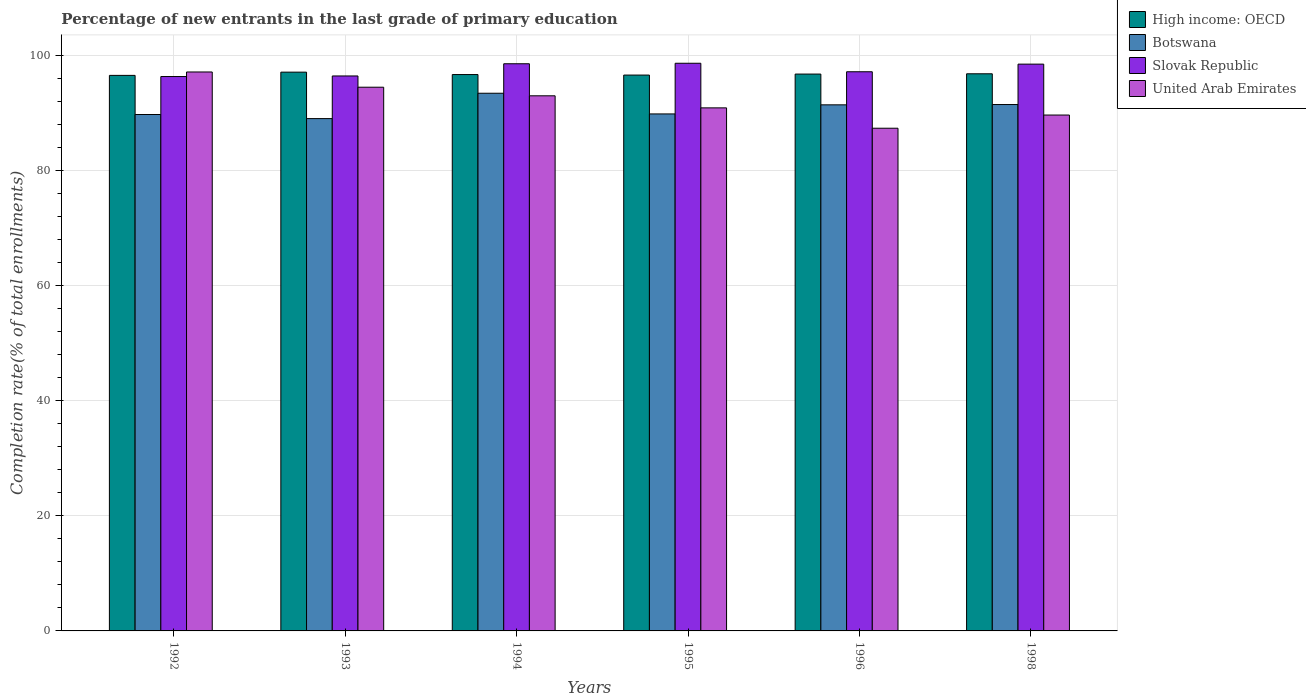Are the number of bars on each tick of the X-axis equal?
Keep it short and to the point. Yes. How many bars are there on the 4th tick from the right?
Your answer should be compact. 4. In how many cases, is the number of bars for a given year not equal to the number of legend labels?
Provide a succinct answer. 0. What is the percentage of new entrants in Slovak Republic in 1996?
Ensure brevity in your answer.  97.13. Across all years, what is the maximum percentage of new entrants in United Arab Emirates?
Ensure brevity in your answer.  97.09. Across all years, what is the minimum percentage of new entrants in Botswana?
Your answer should be compact. 89. In which year was the percentage of new entrants in United Arab Emirates maximum?
Make the answer very short. 1992. What is the total percentage of new entrants in Slovak Republic in the graph?
Offer a terse response. 585.43. What is the difference between the percentage of new entrants in Slovak Republic in 1993 and that in 1998?
Make the answer very short. -2.05. What is the difference between the percentage of new entrants in Slovak Republic in 1992 and the percentage of new entrants in Botswana in 1996?
Your response must be concise. 4.92. What is the average percentage of new entrants in United Arab Emirates per year?
Provide a short and direct response. 92.05. In the year 1996, what is the difference between the percentage of new entrants in United Arab Emirates and percentage of new entrants in Botswana?
Offer a very short reply. -4.06. In how many years, is the percentage of new entrants in Slovak Republic greater than 24 %?
Offer a terse response. 6. What is the ratio of the percentage of new entrants in Botswana in 1994 to that in 1998?
Keep it short and to the point. 1.02. What is the difference between the highest and the second highest percentage of new entrants in United Arab Emirates?
Your answer should be compact. 2.65. What is the difference between the highest and the lowest percentage of new entrants in United Arab Emirates?
Give a very brief answer. 9.77. Is the sum of the percentage of new entrants in United Arab Emirates in 1996 and 1998 greater than the maximum percentage of new entrants in Slovak Republic across all years?
Offer a terse response. Yes. Is it the case that in every year, the sum of the percentage of new entrants in Botswana and percentage of new entrants in Slovak Republic is greater than the sum of percentage of new entrants in United Arab Emirates and percentage of new entrants in High income: OECD?
Offer a very short reply. Yes. What does the 1st bar from the left in 1998 represents?
Provide a short and direct response. High income: OECD. What does the 3rd bar from the right in 1995 represents?
Your answer should be compact. Botswana. Is it the case that in every year, the sum of the percentage of new entrants in Slovak Republic and percentage of new entrants in Botswana is greater than the percentage of new entrants in United Arab Emirates?
Provide a short and direct response. Yes. How many bars are there?
Provide a succinct answer. 24. Does the graph contain any zero values?
Your answer should be compact. No. How many legend labels are there?
Give a very brief answer. 4. How are the legend labels stacked?
Your answer should be compact. Vertical. What is the title of the graph?
Your answer should be very brief. Percentage of new entrants in the last grade of primary education. What is the label or title of the Y-axis?
Your response must be concise. Completion rate(% of total enrollments). What is the Completion rate(% of total enrollments) in High income: OECD in 1992?
Provide a succinct answer. 96.5. What is the Completion rate(% of total enrollments) in Botswana in 1992?
Make the answer very short. 89.71. What is the Completion rate(% of total enrollments) in Slovak Republic in 1992?
Offer a very short reply. 96.3. What is the Completion rate(% of total enrollments) of United Arab Emirates in 1992?
Give a very brief answer. 97.09. What is the Completion rate(% of total enrollments) of High income: OECD in 1993?
Your answer should be compact. 97.07. What is the Completion rate(% of total enrollments) in Botswana in 1993?
Your response must be concise. 89. What is the Completion rate(% of total enrollments) of Slovak Republic in 1993?
Offer a very short reply. 96.4. What is the Completion rate(% of total enrollments) of United Arab Emirates in 1993?
Make the answer very short. 94.45. What is the Completion rate(% of total enrollments) in High income: OECD in 1994?
Offer a very short reply. 96.65. What is the Completion rate(% of total enrollments) of Botswana in 1994?
Provide a succinct answer. 93.4. What is the Completion rate(% of total enrollments) in Slovak Republic in 1994?
Ensure brevity in your answer.  98.52. What is the Completion rate(% of total enrollments) in United Arab Emirates in 1994?
Offer a terse response. 92.96. What is the Completion rate(% of total enrollments) of High income: OECD in 1995?
Your answer should be very brief. 96.56. What is the Completion rate(% of total enrollments) in Botswana in 1995?
Make the answer very short. 89.81. What is the Completion rate(% of total enrollments) in Slovak Republic in 1995?
Keep it short and to the point. 98.61. What is the Completion rate(% of total enrollments) of United Arab Emirates in 1995?
Your answer should be compact. 90.86. What is the Completion rate(% of total enrollments) of High income: OECD in 1996?
Your answer should be very brief. 96.73. What is the Completion rate(% of total enrollments) in Botswana in 1996?
Keep it short and to the point. 91.39. What is the Completion rate(% of total enrollments) in Slovak Republic in 1996?
Give a very brief answer. 97.13. What is the Completion rate(% of total enrollments) in United Arab Emirates in 1996?
Ensure brevity in your answer.  87.32. What is the Completion rate(% of total enrollments) of High income: OECD in 1998?
Offer a very short reply. 96.78. What is the Completion rate(% of total enrollments) of Botswana in 1998?
Offer a very short reply. 91.44. What is the Completion rate(% of total enrollments) in Slovak Republic in 1998?
Offer a very short reply. 98.46. What is the Completion rate(% of total enrollments) of United Arab Emirates in 1998?
Your answer should be very brief. 89.62. Across all years, what is the maximum Completion rate(% of total enrollments) in High income: OECD?
Keep it short and to the point. 97.07. Across all years, what is the maximum Completion rate(% of total enrollments) in Botswana?
Your answer should be compact. 93.4. Across all years, what is the maximum Completion rate(% of total enrollments) in Slovak Republic?
Ensure brevity in your answer.  98.61. Across all years, what is the maximum Completion rate(% of total enrollments) of United Arab Emirates?
Your answer should be very brief. 97.09. Across all years, what is the minimum Completion rate(% of total enrollments) in High income: OECD?
Offer a very short reply. 96.5. Across all years, what is the minimum Completion rate(% of total enrollments) of Botswana?
Offer a terse response. 89. Across all years, what is the minimum Completion rate(% of total enrollments) in Slovak Republic?
Your response must be concise. 96.3. Across all years, what is the minimum Completion rate(% of total enrollments) of United Arab Emirates?
Ensure brevity in your answer.  87.32. What is the total Completion rate(% of total enrollments) in High income: OECD in the graph?
Your answer should be compact. 580.29. What is the total Completion rate(% of total enrollments) in Botswana in the graph?
Make the answer very short. 544.74. What is the total Completion rate(% of total enrollments) of Slovak Republic in the graph?
Give a very brief answer. 585.43. What is the total Completion rate(% of total enrollments) of United Arab Emirates in the graph?
Give a very brief answer. 552.3. What is the difference between the Completion rate(% of total enrollments) in High income: OECD in 1992 and that in 1993?
Provide a short and direct response. -0.56. What is the difference between the Completion rate(% of total enrollments) of Botswana in 1992 and that in 1993?
Your answer should be very brief. 0.71. What is the difference between the Completion rate(% of total enrollments) in Slovak Republic in 1992 and that in 1993?
Provide a short and direct response. -0.1. What is the difference between the Completion rate(% of total enrollments) in United Arab Emirates in 1992 and that in 1993?
Keep it short and to the point. 2.65. What is the difference between the Completion rate(% of total enrollments) in High income: OECD in 1992 and that in 1994?
Give a very brief answer. -0.14. What is the difference between the Completion rate(% of total enrollments) of Botswana in 1992 and that in 1994?
Offer a very short reply. -3.69. What is the difference between the Completion rate(% of total enrollments) in Slovak Republic in 1992 and that in 1994?
Offer a terse response. -2.22. What is the difference between the Completion rate(% of total enrollments) of United Arab Emirates in 1992 and that in 1994?
Ensure brevity in your answer.  4.14. What is the difference between the Completion rate(% of total enrollments) in High income: OECD in 1992 and that in 1995?
Provide a short and direct response. -0.06. What is the difference between the Completion rate(% of total enrollments) in Botswana in 1992 and that in 1995?
Make the answer very short. -0.1. What is the difference between the Completion rate(% of total enrollments) of Slovak Republic in 1992 and that in 1995?
Give a very brief answer. -2.31. What is the difference between the Completion rate(% of total enrollments) in United Arab Emirates in 1992 and that in 1995?
Provide a short and direct response. 6.23. What is the difference between the Completion rate(% of total enrollments) of High income: OECD in 1992 and that in 1996?
Your answer should be compact. -0.23. What is the difference between the Completion rate(% of total enrollments) in Botswana in 1992 and that in 1996?
Ensure brevity in your answer.  -1.68. What is the difference between the Completion rate(% of total enrollments) in Slovak Republic in 1992 and that in 1996?
Your answer should be very brief. -0.83. What is the difference between the Completion rate(% of total enrollments) in United Arab Emirates in 1992 and that in 1996?
Give a very brief answer. 9.77. What is the difference between the Completion rate(% of total enrollments) of High income: OECD in 1992 and that in 1998?
Your answer should be compact. -0.28. What is the difference between the Completion rate(% of total enrollments) in Botswana in 1992 and that in 1998?
Offer a very short reply. -1.73. What is the difference between the Completion rate(% of total enrollments) of Slovak Republic in 1992 and that in 1998?
Offer a very short reply. -2.16. What is the difference between the Completion rate(% of total enrollments) in United Arab Emirates in 1992 and that in 1998?
Make the answer very short. 7.48. What is the difference between the Completion rate(% of total enrollments) in High income: OECD in 1993 and that in 1994?
Your response must be concise. 0.42. What is the difference between the Completion rate(% of total enrollments) in Botswana in 1993 and that in 1994?
Provide a succinct answer. -4.4. What is the difference between the Completion rate(% of total enrollments) of Slovak Republic in 1993 and that in 1994?
Keep it short and to the point. -2.12. What is the difference between the Completion rate(% of total enrollments) in United Arab Emirates in 1993 and that in 1994?
Your response must be concise. 1.49. What is the difference between the Completion rate(% of total enrollments) of High income: OECD in 1993 and that in 1995?
Offer a very short reply. 0.51. What is the difference between the Completion rate(% of total enrollments) of Botswana in 1993 and that in 1995?
Give a very brief answer. -0.81. What is the difference between the Completion rate(% of total enrollments) in Slovak Republic in 1993 and that in 1995?
Offer a very short reply. -2.21. What is the difference between the Completion rate(% of total enrollments) in United Arab Emirates in 1993 and that in 1995?
Offer a terse response. 3.59. What is the difference between the Completion rate(% of total enrollments) of High income: OECD in 1993 and that in 1996?
Make the answer very short. 0.33. What is the difference between the Completion rate(% of total enrollments) of Botswana in 1993 and that in 1996?
Your response must be concise. -2.39. What is the difference between the Completion rate(% of total enrollments) in Slovak Republic in 1993 and that in 1996?
Provide a succinct answer. -0.73. What is the difference between the Completion rate(% of total enrollments) in United Arab Emirates in 1993 and that in 1996?
Provide a short and direct response. 7.13. What is the difference between the Completion rate(% of total enrollments) in High income: OECD in 1993 and that in 1998?
Ensure brevity in your answer.  0.28. What is the difference between the Completion rate(% of total enrollments) of Botswana in 1993 and that in 1998?
Ensure brevity in your answer.  -2.44. What is the difference between the Completion rate(% of total enrollments) in Slovak Republic in 1993 and that in 1998?
Your answer should be very brief. -2.05. What is the difference between the Completion rate(% of total enrollments) of United Arab Emirates in 1993 and that in 1998?
Your response must be concise. 4.83. What is the difference between the Completion rate(% of total enrollments) in High income: OECD in 1994 and that in 1995?
Provide a succinct answer. 0.09. What is the difference between the Completion rate(% of total enrollments) in Botswana in 1994 and that in 1995?
Keep it short and to the point. 3.59. What is the difference between the Completion rate(% of total enrollments) of Slovak Republic in 1994 and that in 1995?
Give a very brief answer. -0.09. What is the difference between the Completion rate(% of total enrollments) in United Arab Emirates in 1994 and that in 1995?
Provide a succinct answer. 2.09. What is the difference between the Completion rate(% of total enrollments) of High income: OECD in 1994 and that in 1996?
Make the answer very short. -0.09. What is the difference between the Completion rate(% of total enrollments) of Botswana in 1994 and that in 1996?
Your answer should be compact. 2.01. What is the difference between the Completion rate(% of total enrollments) of Slovak Republic in 1994 and that in 1996?
Ensure brevity in your answer.  1.39. What is the difference between the Completion rate(% of total enrollments) in United Arab Emirates in 1994 and that in 1996?
Provide a short and direct response. 5.63. What is the difference between the Completion rate(% of total enrollments) of High income: OECD in 1994 and that in 1998?
Your answer should be very brief. -0.13. What is the difference between the Completion rate(% of total enrollments) of Botswana in 1994 and that in 1998?
Make the answer very short. 1.96. What is the difference between the Completion rate(% of total enrollments) in Slovak Republic in 1994 and that in 1998?
Your answer should be very brief. 0.07. What is the difference between the Completion rate(% of total enrollments) of United Arab Emirates in 1994 and that in 1998?
Make the answer very short. 3.34. What is the difference between the Completion rate(% of total enrollments) in High income: OECD in 1995 and that in 1996?
Your answer should be very brief. -0.18. What is the difference between the Completion rate(% of total enrollments) in Botswana in 1995 and that in 1996?
Provide a succinct answer. -1.58. What is the difference between the Completion rate(% of total enrollments) of Slovak Republic in 1995 and that in 1996?
Your answer should be very brief. 1.48. What is the difference between the Completion rate(% of total enrollments) in United Arab Emirates in 1995 and that in 1996?
Offer a terse response. 3.54. What is the difference between the Completion rate(% of total enrollments) of High income: OECD in 1995 and that in 1998?
Give a very brief answer. -0.22. What is the difference between the Completion rate(% of total enrollments) of Botswana in 1995 and that in 1998?
Keep it short and to the point. -1.63. What is the difference between the Completion rate(% of total enrollments) of Slovak Republic in 1995 and that in 1998?
Make the answer very short. 0.15. What is the difference between the Completion rate(% of total enrollments) of United Arab Emirates in 1995 and that in 1998?
Give a very brief answer. 1.25. What is the difference between the Completion rate(% of total enrollments) of High income: OECD in 1996 and that in 1998?
Ensure brevity in your answer.  -0.05. What is the difference between the Completion rate(% of total enrollments) in Botswana in 1996 and that in 1998?
Provide a short and direct response. -0.05. What is the difference between the Completion rate(% of total enrollments) in Slovak Republic in 1996 and that in 1998?
Your response must be concise. -1.32. What is the difference between the Completion rate(% of total enrollments) in United Arab Emirates in 1996 and that in 1998?
Your answer should be compact. -2.29. What is the difference between the Completion rate(% of total enrollments) in High income: OECD in 1992 and the Completion rate(% of total enrollments) in Botswana in 1993?
Offer a very short reply. 7.51. What is the difference between the Completion rate(% of total enrollments) of High income: OECD in 1992 and the Completion rate(% of total enrollments) of Slovak Republic in 1993?
Keep it short and to the point. 0.1. What is the difference between the Completion rate(% of total enrollments) of High income: OECD in 1992 and the Completion rate(% of total enrollments) of United Arab Emirates in 1993?
Provide a succinct answer. 2.05. What is the difference between the Completion rate(% of total enrollments) in Botswana in 1992 and the Completion rate(% of total enrollments) in Slovak Republic in 1993?
Keep it short and to the point. -6.7. What is the difference between the Completion rate(% of total enrollments) of Botswana in 1992 and the Completion rate(% of total enrollments) of United Arab Emirates in 1993?
Your answer should be very brief. -4.74. What is the difference between the Completion rate(% of total enrollments) of Slovak Republic in 1992 and the Completion rate(% of total enrollments) of United Arab Emirates in 1993?
Your response must be concise. 1.85. What is the difference between the Completion rate(% of total enrollments) in High income: OECD in 1992 and the Completion rate(% of total enrollments) in Botswana in 1994?
Make the answer very short. 3.1. What is the difference between the Completion rate(% of total enrollments) in High income: OECD in 1992 and the Completion rate(% of total enrollments) in Slovak Republic in 1994?
Provide a short and direct response. -2.02. What is the difference between the Completion rate(% of total enrollments) of High income: OECD in 1992 and the Completion rate(% of total enrollments) of United Arab Emirates in 1994?
Your answer should be very brief. 3.55. What is the difference between the Completion rate(% of total enrollments) in Botswana in 1992 and the Completion rate(% of total enrollments) in Slovak Republic in 1994?
Your answer should be very brief. -8.82. What is the difference between the Completion rate(% of total enrollments) in Botswana in 1992 and the Completion rate(% of total enrollments) in United Arab Emirates in 1994?
Offer a terse response. -3.25. What is the difference between the Completion rate(% of total enrollments) in Slovak Republic in 1992 and the Completion rate(% of total enrollments) in United Arab Emirates in 1994?
Your answer should be very brief. 3.35. What is the difference between the Completion rate(% of total enrollments) in High income: OECD in 1992 and the Completion rate(% of total enrollments) in Botswana in 1995?
Give a very brief answer. 6.69. What is the difference between the Completion rate(% of total enrollments) of High income: OECD in 1992 and the Completion rate(% of total enrollments) of Slovak Republic in 1995?
Your response must be concise. -2.11. What is the difference between the Completion rate(% of total enrollments) in High income: OECD in 1992 and the Completion rate(% of total enrollments) in United Arab Emirates in 1995?
Provide a short and direct response. 5.64. What is the difference between the Completion rate(% of total enrollments) in Botswana in 1992 and the Completion rate(% of total enrollments) in Slovak Republic in 1995?
Make the answer very short. -8.9. What is the difference between the Completion rate(% of total enrollments) of Botswana in 1992 and the Completion rate(% of total enrollments) of United Arab Emirates in 1995?
Keep it short and to the point. -1.15. What is the difference between the Completion rate(% of total enrollments) of Slovak Republic in 1992 and the Completion rate(% of total enrollments) of United Arab Emirates in 1995?
Your response must be concise. 5.44. What is the difference between the Completion rate(% of total enrollments) of High income: OECD in 1992 and the Completion rate(% of total enrollments) of Botswana in 1996?
Your response must be concise. 5.12. What is the difference between the Completion rate(% of total enrollments) of High income: OECD in 1992 and the Completion rate(% of total enrollments) of Slovak Republic in 1996?
Provide a succinct answer. -0.63. What is the difference between the Completion rate(% of total enrollments) of High income: OECD in 1992 and the Completion rate(% of total enrollments) of United Arab Emirates in 1996?
Your answer should be compact. 9.18. What is the difference between the Completion rate(% of total enrollments) of Botswana in 1992 and the Completion rate(% of total enrollments) of Slovak Republic in 1996?
Provide a short and direct response. -7.43. What is the difference between the Completion rate(% of total enrollments) of Botswana in 1992 and the Completion rate(% of total enrollments) of United Arab Emirates in 1996?
Your answer should be compact. 2.38. What is the difference between the Completion rate(% of total enrollments) of Slovak Republic in 1992 and the Completion rate(% of total enrollments) of United Arab Emirates in 1996?
Offer a very short reply. 8.98. What is the difference between the Completion rate(% of total enrollments) in High income: OECD in 1992 and the Completion rate(% of total enrollments) in Botswana in 1998?
Offer a terse response. 5.06. What is the difference between the Completion rate(% of total enrollments) of High income: OECD in 1992 and the Completion rate(% of total enrollments) of Slovak Republic in 1998?
Give a very brief answer. -1.95. What is the difference between the Completion rate(% of total enrollments) in High income: OECD in 1992 and the Completion rate(% of total enrollments) in United Arab Emirates in 1998?
Give a very brief answer. 6.89. What is the difference between the Completion rate(% of total enrollments) of Botswana in 1992 and the Completion rate(% of total enrollments) of Slovak Republic in 1998?
Keep it short and to the point. -8.75. What is the difference between the Completion rate(% of total enrollments) in Botswana in 1992 and the Completion rate(% of total enrollments) in United Arab Emirates in 1998?
Ensure brevity in your answer.  0.09. What is the difference between the Completion rate(% of total enrollments) in Slovak Republic in 1992 and the Completion rate(% of total enrollments) in United Arab Emirates in 1998?
Make the answer very short. 6.69. What is the difference between the Completion rate(% of total enrollments) of High income: OECD in 1993 and the Completion rate(% of total enrollments) of Botswana in 1994?
Provide a succinct answer. 3.66. What is the difference between the Completion rate(% of total enrollments) of High income: OECD in 1993 and the Completion rate(% of total enrollments) of Slovak Republic in 1994?
Give a very brief answer. -1.46. What is the difference between the Completion rate(% of total enrollments) of High income: OECD in 1993 and the Completion rate(% of total enrollments) of United Arab Emirates in 1994?
Make the answer very short. 4.11. What is the difference between the Completion rate(% of total enrollments) of Botswana in 1993 and the Completion rate(% of total enrollments) of Slovak Republic in 1994?
Your response must be concise. -9.53. What is the difference between the Completion rate(% of total enrollments) of Botswana in 1993 and the Completion rate(% of total enrollments) of United Arab Emirates in 1994?
Provide a short and direct response. -3.96. What is the difference between the Completion rate(% of total enrollments) in Slovak Republic in 1993 and the Completion rate(% of total enrollments) in United Arab Emirates in 1994?
Keep it short and to the point. 3.45. What is the difference between the Completion rate(% of total enrollments) of High income: OECD in 1993 and the Completion rate(% of total enrollments) of Botswana in 1995?
Your response must be concise. 7.26. What is the difference between the Completion rate(% of total enrollments) of High income: OECD in 1993 and the Completion rate(% of total enrollments) of Slovak Republic in 1995?
Make the answer very short. -1.54. What is the difference between the Completion rate(% of total enrollments) of High income: OECD in 1993 and the Completion rate(% of total enrollments) of United Arab Emirates in 1995?
Provide a succinct answer. 6.2. What is the difference between the Completion rate(% of total enrollments) in Botswana in 1993 and the Completion rate(% of total enrollments) in Slovak Republic in 1995?
Provide a short and direct response. -9.61. What is the difference between the Completion rate(% of total enrollments) in Botswana in 1993 and the Completion rate(% of total enrollments) in United Arab Emirates in 1995?
Provide a short and direct response. -1.86. What is the difference between the Completion rate(% of total enrollments) of Slovak Republic in 1993 and the Completion rate(% of total enrollments) of United Arab Emirates in 1995?
Provide a succinct answer. 5.54. What is the difference between the Completion rate(% of total enrollments) of High income: OECD in 1993 and the Completion rate(% of total enrollments) of Botswana in 1996?
Your answer should be compact. 5.68. What is the difference between the Completion rate(% of total enrollments) in High income: OECD in 1993 and the Completion rate(% of total enrollments) in Slovak Republic in 1996?
Your response must be concise. -0.07. What is the difference between the Completion rate(% of total enrollments) of High income: OECD in 1993 and the Completion rate(% of total enrollments) of United Arab Emirates in 1996?
Make the answer very short. 9.74. What is the difference between the Completion rate(% of total enrollments) in Botswana in 1993 and the Completion rate(% of total enrollments) in Slovak Republic in 1996?
Offer a very short reply. -8.14. What is the difference between the Completion rate(% of total enrollments) in Botswana in 1993 and the Completion rate(% of total enrollments) in United Arab Emirates in 1996?
Ensure brevity in your answer.  1.67. What is the difference between the Completion rate(% of total enrollments) of Slovak Republic in 1993 and the Completion rate(% of total enrollments) of United Arab Emirates in 1996?
Offer a very short reply. 9.08. What is the difference between the Completion rate(% of total enrollments) of High income: OECD in 1993 and the Completion rate(% of total enrollments) of Botswana in 1998?
Make the answer very short. 5.62. What is the difference between the Completion rate(% of total enrollments) in High income: OECD in 1993 and the Completion rate(% of total enrollments) in Slovak Republic in 1998?
Your answer should be compact. -1.39. What is the difference between the Completion rate(% of total enrollments) of High income: OECD in 1993 and the Completion rate(% of total enrollments) of United Arab Emirates in 1998?
Offer a terse response. 7.45. What is the difference between the Completion rate(% of total enrollments) of Botswana in 1993 and the Completion rate(% of total enrollments) of Slovak Republic in 1998?
Make the answer very short. -9.46. What is the difference between the Completion rate(% of total enrollments) of Botswana in 1993 and the Completion rate(% of total enrollments) of United Arab Emirates in 1998?
Offer a very short reply. -0.62. What is the difference between the Completion rate(% of total enrollments) of Slovak Republic in 1993 and the Completion rate(% of total enrollments) of United Arab Emirates in 1998?
Ensure brevity in your answer.  6.79. What is the difference between the Completion rate(% of total enrollments) in High income: OECD in 1994 and the Completion rate(% of total enrollments) in Botswana in 1995?
Give a very brief answer. 6.84. What is the difference between the Completion rate(% of total enrollments) in High income: OECD in 1994 and the Completion rate(% of total enrollments) in Slovak Republic in 1995?
Offer a terse response. -1.96. What is the difference between the Completion rate(% of total enrollments) in High income: OECD in 1994 and the Completion rate(% of total enrollments) in United Arab Emirates in 1995?
Make the answer very short. 5.79. What is the difference between the Completion rate(% of total enrollments) of Botswana in 1994 and the Completion rate(% of total enrollments) of Slovak Republic in 1995?
Provide a short and direct response. -5.21. What is the difference between the Completion rate(% of total enrollments) in Botswana in 1994 and the Completion rate(% of total enrollments) in United Arab Emirates in 1995?
Make the answer very short. 2.54. What is the difference between the Completion rate(% of total enrollments) of Slovak Republic in 1994 and the Completion rate(% of total enrollments) of United Arab Emirates in 1995?
Your response must be concise. 7.66. What is the difference between the Completion rate(% of total enrollments) in High income: OECD in 1994 and the Completion rate(% of total enrollments) in Botswana in 1996?
Keep it short and to the point. 5.26. What is the difference between the Completion rate(% of total enrollments) in High income: OECD in 1994 and the Completion rate(% of total enrollments) in Slovak Republic in 1996?
Provide a short and direct response. -0.49. What is the difference between the Completion rate(% of total enrollments) in High income: OECD in 1994 and the Completion rate(% of total enrollments) in United Arab Emirates in 1996?
Your answer should be very brief. 9.32. What is the difference between the Completion rate(% of total enrollments) in Botswana in 1994 and the Completion rate(% of total enrollments) in Slovak Republic in 1996?
Make the answer very short. -3.73. What is the difference between the Completion rate(% of total enrollments) of Botswana in 1994 and the Completion rate(% of total enrollments) of United Arab Emirates in 1996?
Your answer should be very brief. 6.08. What is the difference between the Completion rate(% of total enrollments) in Slovak Republic in 1994 and the Completion rate(% of total enrollments) in United Arab Emirates in 1996?
Make the answer very short. 11.2. What is the difference between the Completion rate(% of total enrollments) in High income: OECD in 1994 and the Completion rate(% of total enrollments) in Botswana in 1998?
Keep it short and to the point. 5.21. What is the difference between the Completion rate(% of total enrollments) in High income: OECD in 1994 and the Completion rate(% of total enrollments) in Slovak Republic in 1998?
Make the answer very short. -1.81. What is the difference between the Completion rate(% of total enrollments) in High income: OECD in 1994 and the Completion rate(% of total enrollments) in United Arab Emirates in 1998?
Ensure brevity in your answer.  7.03. What is the difference between the Completion rate(% of total enrollments) of Botswana in 1994 and the Completion rate(% of total enrollments) of Slovak Republic in 1998?
Your answer should be very brief. -5.06. What is the difference between the Completion rate(% of total enrollments) in Botswana in 1994 and the Completion rate(% of total enrollments) in United Arab Emirates in 1998?
Give a very brief answer. 3.79. What is the difference between the Completion rate(% of total enrollments) in Slovak Republic in 1994 and the Completion rate(% of total enrollments) in United Arab Emirates in 1998?
Make the answer very short. 8.91. What is the difference between the Completion rate(% of total enrollments) in High income: OECD in 1995 and the Completion rate(% of total enrollments) in Botswana in 1996?
Offer a terse response. 5.17. What is the difference between the Completion rate(% of total enrollments) of High income: OECD in 1995 and the Completion rate(% of total enrollments) of Slovak Republic in 1996?
Keep it short and to the point. -0.58. What is the difference between the Completion rate(% of total enrollments) in High income: OECD in 1995 and the Completion rate(% of total enrollments) in United Arab Emirates in 1996?
Provide a succinct answer. 9.23. What is the difference between the Completion rate(% of total enrollments) of Botswana in 1995 and the Completion rate(% of total enrollments) of Slovak Republic in 1996?
Give a very brief answer. -7.33. What is the difference between the Completion rate(% of total enrollments) in Botswana in 1995 and the Completion rate(% of total enrollments) in United Arab Emirates in 1996?
Provide a succinct answer. 2.48. What is the difference between the Completion rate(% of total enrollments) of Slovak Republic in 1995 and the Completion rate(% of total enrollments) of United Arab Emirates in 1996?
Offer a terse response. 11.29. What is the difference between the Completion rate(% of total enrollments) of High income: OECD in 1995 and the Completion rate(% of total enrollments) of Botswana in 1998?
Give a very brief answer. 5.12. What is the difference between the Completion rate(% of total enrollments) of High income: OECD in 1995 and the Completion rate(% of total enrollments) of Slovak Republic in 1998?
Provide a short and direct response. -1.9. What is the difference between the Completion rate(% of total enrollments) of High income: OECD in 1995 and the Completion rate(% of total enrollments) of United Arab Emirates in 1998?
Your response must be concise. 6.94. What is the difference between the Completion rate(% of total enrollments) in Botswana in 1995 and the Completion rate(% of total enrollments) in Slovak Republic in 1998?
Keep it short and to the point. -8.65. What is the difference between the Completion rate(% of total enrollments) of Botswana in 1995 and the Completion rate(% of total enrollments) of United Arab Emirates in 1998?
Offer a very short reply. 0.19. What is the difference between the Completion rate(% of total enrollments) of Slovak Republic in 1995 and the Completion rate(% of total enrollments) of United Arab Emirates in 1998?
Your response must be concise. 8.99. What is the difference between the Completion rate(% of total enrollments) in High income: OECD in 1996 and the Completion rate(% of total enrollments) in Botswana in 1998?
Your answer should be very brief. 5.29. What is the difference between the Completion rate(% of total enrollments) in High income: OECD in 1996 and the Completion rate(% of total enrollments) in Slovak Republic in 1998?
Your answer should be compact. -1.72. What is the difference between the Completion rate(% of total enrollments) in High income: OECD in 1996 and the Completion rate(% of total enrollments) in United Arab Emirates in 1998?
Keep it short and to the point. 7.12. What is the difference between the Completion rate(% of total enrollments) of Botswana in 1996 and the Completion rate(% of total enrollments) of Slovak Republic in 1998?
Provide a short and direct response. -7.07. What is the difference between the Completion rate(% of total enrollments) in Botswana in 1996 and the Completion rate(% of total enrollments) in United Arab Emirates in 1998?
Ensure brevity in your answer.  1.77. What is the difference between the Completion rate(% of total enrollments) of Slovak Republic in 1996 and the Completion rate(% of total enrollments) of United Arab Emirates in 1998?
Your response must be concise. 7.52. What is the average Completion rate(% of total enrollments) of High income: OECD per year?
Offer a very short reply. 96.71. What is the average Completion rate(% of total enrollments) in Botswana per year?
Make the answer very short. 90.79. What is the average Completion rate(% of total enrollments) of Slovak Republic per year?
Ensure brevity in your answer.  97.57. What is the average Completion rate(% of total enrollments) in United Arab Emirates per year?
Your answer should be very brief. 92.05. In the year 1992, what is the difference between the Completion rate(% of total enrollments) in High income: OECD and Completion rate(% of total enrollments) in Botswana?
Offer a very short reply. 6.79. In the year 1992, what is the difference between the Completion rate(% of total enrollments) in High income: OECD and Completion rate(% of total enrollments) in Slovak Republic?
Your answer should be compact. 0.2. In the year 1992, what is the difference between the Completion rate(% of total enrollments) in High income: OECD and Completion rate(% of total enrollments) in United Arab Emirates?
Provide a short and direct response. -0.59. In the year 1992, what is the difference between the Completion rate(% of total enrollments) in Botswana and Completion rate(% of total enrollments) in Slovak Republic?
Make the answer very short. -6.59. In the year 1992, what is the difference between the Completion rate(% of total enrollments) of Botswana and Completion rate(% of total enrollments) of United Arab Emirates?
Offer a very short reply. -7.39. In the year 1992, what is the difference between the Completion rate(% of total enrollments) in Slovak Republic and Completion rate(% of total enrollments) in United Arab Emirates?
Your response must be concise. -0.79. In the year 1993, what is the difference between the Completion rate(% of total enrollments) of High income: OECD and Completion rate(% of total enrollments) of Botswana?
Provide a short and direct response. 8.07. In the year 1993, what is the difference between the Completion rate(% of total enrollments) in High income: OECD and Completion rate(% of total enrollments) in Slovak Republic?
Your response must be concise. 0.66. In the year 1993, what is the difference between the Completion rate(% of total enrollments) in High income: OECD and Completion rate(% of total enrollments) in United Arab Emirates?
Your response must be concise. 2.62. In the year 1993, what is the difference between the Completion rate(% of total enrollments) of Botswana and Completion rate(% of total enrollments) of Slovak Republic?
Offer a very short reply. -7.41. In the year 1993, what is the difference between the Completion rate(% of total enrollments) of Botswana and Completion rate(% of total enrollments) of United Arab Emirates?
Make the answer very short. -5.45. In the year 1993, what is the difference between the Completion rate(% of total enrollments) of Slovak Republic and Completion rate(% of total enrollments) of United Arab Emirates?
Your response must be concise. 1.95. In the year 1994, what is the difference between the Completion rate(% of total enrollments) in High income: OECD and Completion rate(% of total enrollments) in Botswana?
Your answer should be very brief. 3.25. In the year 1994, what is the difference between the Completion rate(% of total enrollments) in High income: OECD and Completion rate(% of total enrollments) in Slovak Republic?
Keep it short and to the point. -1.88. In the year 1994, what is the difference between the Completion rate(% of total enrollments) of High income: OECD and Completion rate(% of total enrollments) of United Arab Emirates?
Your response must be concise. 3.69. In the year 1994, what is the difference between the Completion rate(% of total enrollments) of Botswana and Completion rate(% of total enrollments) of Slovak Republic?
Make the answer very short. -5.12. In the year 1994, what is the difference between the Completion rate(% of total enrollments) of Botswana and Completion rate(% of total enrollments) of United Arab Emirates?
Ensure brevity in your answer.  0.44. In the year 1994, what is the difference between the Completion rate(% of total enrollments) of Slovak Republic and Completion rate(% of total enrollments) of United Arab Emirates?
Offer a very short reply. 5.57. In the year 1995, what is the difference between the Completion rate(% of total enrollments) in High income: OECD and Completion rate(% of total enrollments) in Botswana?
Provide a short and direct response. 6.75. In the year 1995, what is the difference between the Completion rate(% of total enrollments) in High income: OECD and Completion rate(% of total enrollments) in Slovak Republic?
Your answer should be compact. -2.05. In the year 1995, what is the difference between the Completion rate(% of total enrollments) of High income: OECD and Completion rate(% of total enrollments) of United Arab Emirates?
Give a very brief answer. 5.7. In the year 1995, what is the difference between the Completion rate(% of total enrollments) of Botswana and Completion rate(% of total enrollments) of Slovak Republic?
Ensure brevity in your answer.  -8.8. In the year 1995, what is the difference between the Completion rate(% of total enrollments) in Botswana and Completion rate(% of total enrollments) in United Arab Emirates?
Keep it short and to the point. -1.05. In the year 1995, what is the difference between the Completion rate(% of total enrollments) in Slovak Republic and Completion rate(% of total enrollments) in United Arab Emirates?
Offer a very short reply. 7.75. In the year 1996, what is the difference between the Completion rate(% of total enrollments) in High income: OECD and Completion rate(% of total enrollments) in Botswana?
Ensure brevity in your answer.  5.35. In the year 1996, what is the difference between the Completion rate(% of total enrollments) in High income: OECD and Completion rate(% of total enrollments) in Slovak Republic?
Offer a terse response. -0.4. In the year 1996, what is the difference between the Completion rate(% of total enrollments) in High income: OECD and Completion rate(% of total enrollments) in United Arab Emirates?
Your answer should be very brief. 9.41. In the year 1996, what is the difference between the Completion rate(% of total enrollments) of Botswana and Completion rate(% of total enrollments) of Slovak Republic?
Give a very brief answer. -5.75. In the year 1996, what is the difference between the Completion rate(% of total enrollments) in Botswana and Completion rate(% of total enrollments) in United Arab Emirates?
Provide a short and direct response. 4.06. In the year 1996, what is the difference between the Completion rate(% of total enrollments) in Slovak Republic and Completion rate(% of total enrollments) in United Arab Emirates?
Give a very brief answer. 9.81. In the year 1998, what is the difference between the Completion rate(% of total enrollments) in High income: OECD and Completion rate(% of total enrollments) in Botswana?
Make the answer very short. 5.34. In the year 1998, what is the difference between the Completion rate(% of total enrollments) in High income: OECD and Completion rate(% of total enrollments) in Slovak Republic?
Provide a short and direct response. -1.68. In the year 1998, what is the difference between the Completion rate(% of total enrollments) of High income: OECD and Completion rate(% of total enrollments) of United Arab Emirates?
Ensure brevity in your answer.  7.17. In the year 1998, what is the difference between the Completion rate(% of total enrollments) in Botswana and Completion rate(% of total enrollments) in Slovak Republic?
Ensure brevity in your answer.  -7.02. In the year 1998, what is the difference between the Completion rate(% of total enrollments) of Botswana and Completion rate(% of total enrollments) of United Arab Emirates?
Provide a succinct answer. 1.82. In the year 1998, what is the difference between the Completion rate(% of total enrollments) in Slovak Republic and Completion rate(% of total enrollments) in United Arab Emirates?
Ensure brevity in your answer.  8.84. What is the ratio of the Completion rate(% of total enrollments) of Botswana in 1992 to that in 1993?
Offer a terse response. 1.01. What is the ratio of the Completion rate(% of total enrollments) of United Arab Emirates in 1992 to that in 1993?
Provide a short and direct response. 1.03. What is the ratio of the Completion rate(% of total enrollments) of Botswana in 1992 to that in 1994?
Provide a short and direct response. 0.96. What is the ratio of the Completion rate(% of total enrollments) in Slovak Republic in 1992 to that in 1994?
Make the answer very short. 0.98. What is the ratio of the Completion rate(% of total enrollments) of United Arab Emirates in 1992 to that in 1994?
Your answer should be compact. 1.04. What is the ratio of the Completion rate(% of total enrollments) in High income: OECD in 1992 to that in 1995?
Keep it short and to the point. 1. What is the ratio of the Completion rate(% of total enrollments) of Slovak Republic in 1992 to that in 1995?
Your response must be concise. 0.98. What is the ratio of the Completion rate(% of total enrollments) of United Arab Emirates in 1992 to that in 1995?
Your answer should be compact. 1.07. What is the ratio of the Completion rate(% of total enrollments) of Botswana in 1992 to that in 1996?
Give a very brief answer. 0.98. What is the ratio of the Completion rate(% of total enrollments) of Slovak Republic in 1992 to that in 1996?
Provide a short and direct response. 0.99. What is the ratio of the Completion rate(% of total enrollments) of United Arab Emirates in 1992 to that in 1996?
Offer a very short reply. 1.11. What is the ratio of the Completion rate(% of total enrollments) of High income: OECD in 1992 to that in 1998?
Provide a succinct answer. 1. What is the ratio of the Completion rate(% of total enrollments) of Botswana in 1992 to that in 1998?
Your answer should be very brief. 0.98. What is the ratio of the Completion rate(% of total enrollments) in Slovak Republic in 1992 to that in 1998?
Ensure brevity in your answer.  0.98. What is the ratio of the Completion rate(% of total enrollments) in United Arab Emirates in 1992 to that in 1998?
Your answer should be very brief. 1.08. What is the ratio of the Completion rate(% of total enrollments) in High income: OECD in 1993 to that in 1994?
Provide a short and direct response. 1. What is the ratio of the Completion rate(% of total enrollments) of Botswana in 1993 to that in 1994?
Make the answer very short. 0.95. What is the ratio of the Completion rate(% of total enrollments) of Slovak Republic in 1993 to that in 1994?
Make the answer very short. 0.98. What is the ratio of the Completion rate(% of total enrollments) of United Arab Emirates in 1993 to that in 1994?
Ensure brevity in your answer.  1.02. What is the ratio of the Completion rate(% of total enrollments) in High income: OECD in 1993 to that in 1995?
Offer a terse response. 1.01. What is the ratio of the Completion rate(% of total enrollments) in Botswana in 1993 to that in 1995?
Give a very brief answer. 0.99. What is the ratio of the Completion rate(% of total enrollments) of Slovak Republic in 1993 to that in 1995?
Keep it short and to the point. 0.98. What is the ratio of the Completion rate(% of total enrollments) of United Arab Emirates in 1993 to that in 1995?
Make the answer very short. 1.04. What is the ratio of the Completion rate(% of total enrollments) in High income: OECD in 1993 to that in 1996?
Ensure brevity in your answer.  1. What is the ratio of the Completion rate(% of total enrollments) of Botswana in 1993 to that in 1996?
Your answer should be compact. 0.97. What is the ratio of the Completion rate(% of total enrollments) of United Arab Emirates in 1993 to that in 1996?
Provide a short and direct response. 1.08. What is the ratio of the Completion rate(% of total enrollments) in Botswana in 1993 to that in 1998?
Offer a terse response. 0.97. What is the ratio of the Completion rate(% of total enrollments) of Slovak Republic in 1993 to that in 1998?
Your answer should be compact. 0.98. What is the ratio of the Completion rate(% of total enrollments) of United Arab Emirates in 1993 to that in 1998?
Give a very brief answer. 1.05. What is the ratio of the Completion rate(% of total enrollments) in Slovak Republic in 1994 to that in 1995?
Offer a terse response. 1. What is the ratio of the Completion rate(% of total enrollments) of United Arab Emirates in 1994 to that in 1995?
Offer a very short reply. 1.02. What is the ratio of the Completion rate(% of total enrollments) in High income: OECD in 1994 to that in 1996?
Provide a short and direct response. 1. What is the ratio of the Completion rate(% of total enrollments) of Slovak Republic in 1994 to that in 1996?
Your answer should be very brief. 1.01. What is the ratio of the Completion rate(% of total enrollments) of United Arab Emirates in 1994 to that in 1996?
Your answer should be compact. 1.06. What is the ratio of the Completion rate(% of total enrollments) of Botswana in 1994 to that in 1998?
Your response must be concise. 1.02. What is the ratio of the Completion rate(% of total enrollments) of Slovak Republic in 1994 to that in 1998?
Your answer should be very brief. 1. What is the ratio of the Completion rate(% of total enrollments) of United Arab Emirates in 1994 to that in 1998?
Ensure brevity in your answer.  1.04. What is the ratio of the Completion rate(% of total enrollments) in High income: OECD in 1995 to that in 1996?
Keep it short and to the point. 1. What is the ratio of the Completion rate(% of total enrollments) in Botswana in 1995 to that in 1996?
Your answer should be compact. 0.98. What is the ratio of the Completion rate(% of total enrollments) of Slovak Republic in 1995 to that in 1996?
Your response must be concise. 1.02. What is the ratio of the Completion rate(% of total enrollments) in United Arab Emirates in 1995 to that in 1996?
Keep it short and to the point. 1.04. What is the ratio of the Completion rate(% of total enrollments) in High income: OECD in 1995 to that in 1998?
Keep it short and to the point. 1. What is the ratio of the Completion rate(% of total enrollments) of Botswana in 1995 to that in 1998?
Provide a succinct answer. 0.98. What is the ratio of the Completion rate(% of total enrollments) in Slovak Republic in 1995 to that in 1998?
Your answer should be very brief. 1. What is the ratio of the Completion rate(% of total enrollments) in United Arab Emirates in 1995 to that in 1998?
Provide a short and direct response. 1.01. What is the ratio of the Completion rate(% of total enrollments) of High income: OECD in 1996 to that in 1998?
Offer a very short reply. 1. What is the ratio of the Completion rate(% of total enrollments) of Slovak Republic in 1996 to that in 1998?
Give a very brief answer. 0.99. What is the ratio of the Completion rate(% of total enrollments) in United Arab Emirates in 1996 to that in 1998?
Give a very brief answer. 0.97. What is the difference between the highest and the second highest Completion rate(% of total enrollments) of High income: OECD?
Make the answer very short. 0.28. What is the difference between the highest and the second highest Completion rate(% of total enrollments) of Botswana?
Ensure brevity in your answer.  1.96. What is the difference between the highest and the second highest Completion rate(% of total enrollments) in Slovak Republic?
Your answer should be compact. 0.09. What is the difference between the highest and the second highest Completion rate(% of total enrollments) in United Arab Emirates?
Your answer should be compact. 2.65. What is the difference between the highest and the lowest Completion rate(% of total enrollments) in High income: OECD?
Keep it short and to the point. 0.56. What is the difference between the highest and the lowest Completion rate(% of total enrollments) of Botswana?
Make the answer very short. 4.4. What is the difference between the highest and the lowest Completion rate(% of total enrollments) in Slovak Republic?
Ensure brevity in your answer.  2.31. What is the difference between the highest and the lowest Completion rate(% of total enrollments) of United Arab Emirates?
Provide a succinct answer. 9.77. 